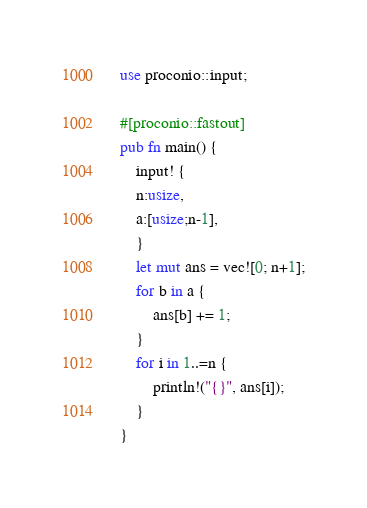Convert code to text. <code><loc_0><loc_0><loc_500><loc_500><_Rust_>use proconio::input;

#[proconio::fastout]
pub fn main() {
    input! {
    n:usize,
    a:[usize;n-1],
    }
    let mut ans = vec![0; n+1];
    for b in a {
        ans[b] += 1;
    }
    for i in 1..=n {
        println!("{}", ans[i]);
    }
}
</code> 